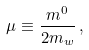<formula> <loc_0><loc_0><loc_500><loc_500>\mu \equiv \frac { m ^ { 0 } } { 2 m _ { w } } \, ,</formula> 